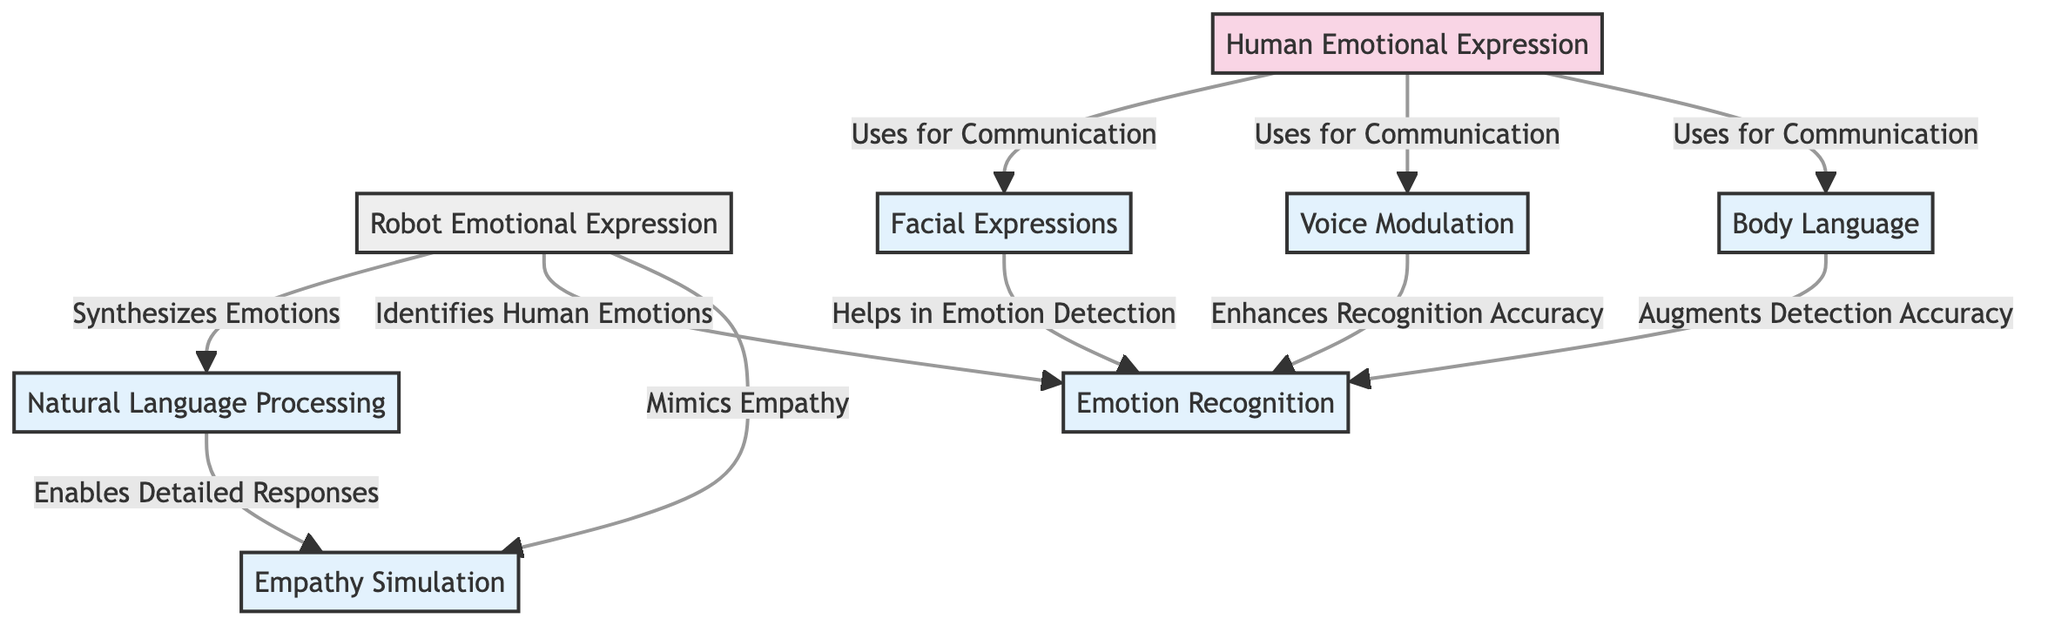What are the two main categories of emotional expression shown in the diagram? The diagram clearly divides emotional expression into two main categories: 'Human Emotional Expression' and 'Robot Emotional Expression.'
Answer: Human Emotional Expression, Robot Emotional Expression How many types of emotional expressions are identified for humans in the diagram? According to the diagram, there are three types identified for humans: 'Facial Expressions', 'Voice Modulation', and 'Body Language', which leads to a total of three.
Answer: 3 What is the common aspect connecting all forms of emotional expression? The connections between the nodes indicate that all types of emotional expressions (like facial expressions and voice modulation) relate to 'Emotion Recognition', showing its importance in understanding emotions.
Answer: Emotion Recognition Which aspect of emotional expression allows robots to identify human emotions? The diagram links 'Identifies Human Emotions' to 'Emotion Recognition,' indicating that robots rely on this method to understand human feelings.
Answer: Emotion Recognition How does 'Natural Language Processing' contribute to robot emotional expression? The diagram suggests that 'Natural Language Processing' enables robots to 'Enables Detailed Responses', meaning it helps robots better respond to human emotions through language.
Answer: Enables Detailed Responses What is the relationship between 'Facial Expressions' and 'Emotion Recognition'? The diagram shows that 'Facial Expressions' help in 'Emotion Detection', establishing a direct relationship where facial expressions contribute to recognizing emotions.
Answer: Helps in Emotion Detection What is the total number of edges connecting the nodes in the diagram? By observing the connections, there are seven edges that connect various aspects of both human and robot emotional expressions, indicating the interrelationships.
Answer: 7 Which type of language is used by robots to mimic empathy according to the diagram? The diagram indicates that robots use 'Natural Language Processing' to 'Mimics Empathy', showing the type of language utilized in their interactions.
Answer: Natural Language Processing What does 'Empathy Simulation' rely on according to the relationships depicted? The diagram shows that 'Empathy Simulation' is linked to 'Emotion Recognition', signifying that the ability to recognize emotions is crucial for simulating empathy in robots.
Answer: Emotion Recognition 